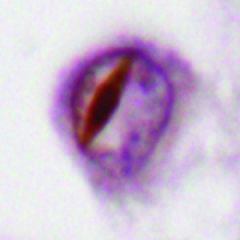what are some forms of ftld associated with?
Answer the question using a single word or phrase. Neuronal intranuclear inclusions containing tdp43 